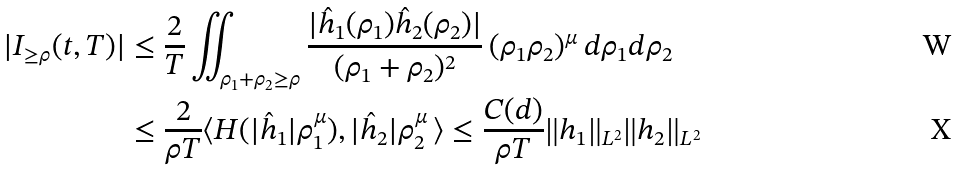Convert formula to latex. <formula><loc_0><loc_0><loc_500><loc_500>| I _ { \geq \rho } ( t , T ) | & \leq \frac { 2 } { T } \iint _ { \rho _ { 1 } + \rho _ { 2 } \geq \rho } \frac { | \hat { h } _ { 1 } ( \rho _ { 1 } ) \hat { h } _ { 2 } ( \rho _ { 2 } ) | } { ( \rho _ { 1 } + \rho _ { 2 } ) ^ { 2 } } \, ( \rho _ { 1 } \rho _ { 2 } ) ^ { \mu } \, d \rho _ { 1 } d \rho _ { 2 } \\ & \leq \frac { 2 } { \rho T } \langle H ( | \hat { h } _ { 1 } | \rho _ { 1 } ^ { \mu } ) , | \hat { h } _ { 2 } | \rho _ { 2 } ^ { \mu } \, \rangle \leq \frac { C ( d ) } { \rho T } \| h _ { 1 } \| _ { L ^ { 2 } } \| h _ { 2 } \| _ { L ^ { 2 } }</formula> 